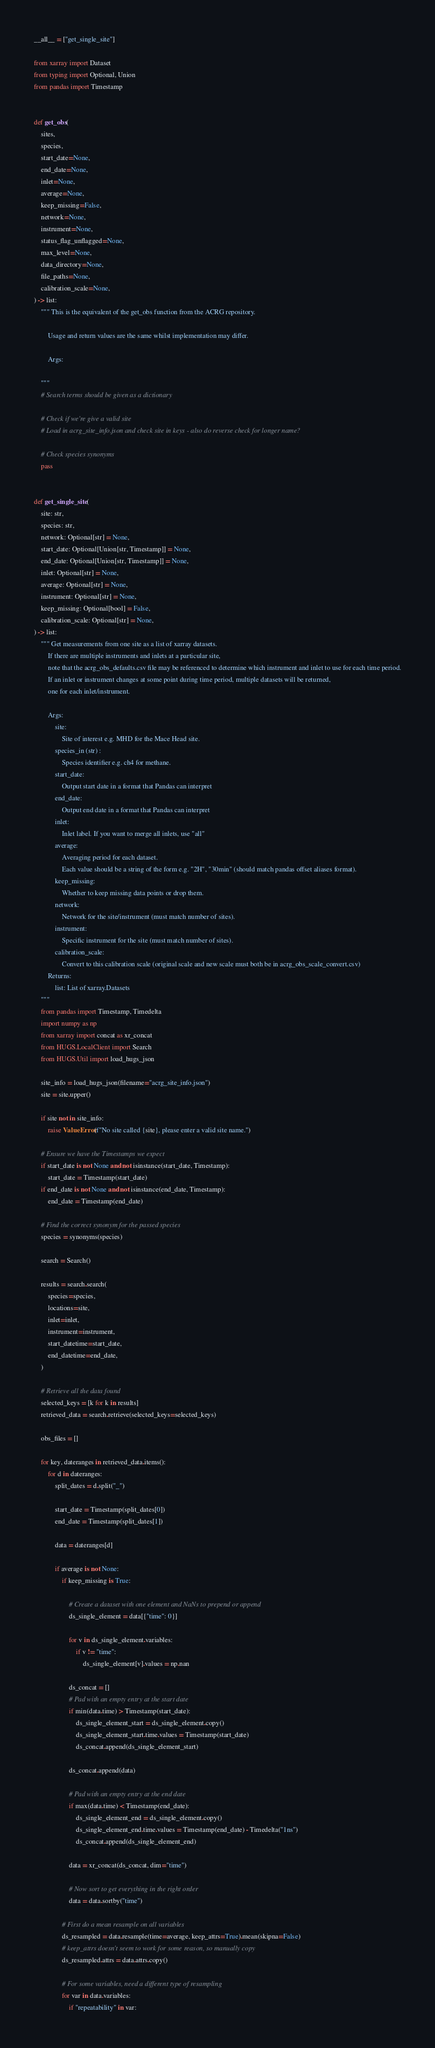<code> <loc_0><loc_0><loc_500><loc_500><_Python_>__all__ = ["get_single_site"]

from xarray import Dataset
from typing import Optional, Union
from pandas import Timestamp


def get_obs(
    sites,
    species,
    start_date=None,
    end_date=None,
    inlet=None,
    average=None,
    keep_missing=False,
    network=None,
    instrument=None,
    status_flag_unflagged=None,
    max_level=None,
    data_directory=None,
    file_paths=None,
    calibration_scale=None,
) -> list:
    """ This is the equivalent of the get_obs function from the ACRG repository.

        Usage and return values are the same whilst implementation may differ.

        Args:

    """
    # Search terms should be given as a dictionary

    # Check if we're give a valid site
    # Load in acrg_site_info.json and check site in keys - also do reverse check for longer name?

    # Check species synonyms
    pass


def get_single_site(
    site: str,
    species: str,
    network: Optional[str] = None,
    start_date: Optional[Union[str, Timestamp]] = None,
    end_date: Optional[Union[str, Timestamp]] = None,
    inlet: Optional[str] = None,
    average: Optional[str] = None,
    instrument: Optional[str] = None,
    keep_missing: Optional[bool] = False,
    calibration_scale: Optional[str] = None,
) -> list:
    """ Get measurements from one site as a list of xarray datasets.
        If there are multiple instruments and inlets at a particular site, 
        note that the acrg_obs_defaults.csv file may be referenced to determine which instrument and inlet to use for each time period.
        If an inlet or instrument changes at some point during time period, multiple datasets will be returned,
        one for each inlet/instrument.

        Args:    
            site:
                Site of interest e.g. MHD for the Mace Head site.
            species_in (str) :
                Species identifier e.g. ch4 for methane.
            start_date: 
                Output start date in a format that Pandas can interpret
            end_date: 
                Output end date in a format that Pandas can interpret
            inlet: 
                Inlet label. If you want to merge all inlets, use "all"
            average:
                Averaging period for each dataset.
                Each value should be a string of the form e.g. "2H", "30min" (should match pandas offset aliases format).
            keep_missing:
                Whether to keep missing data points or drop them.
            network: 
                Network for the site/instrument (must match number of sites).
            instrument:
                Specific instrument for the site (must match number of sites). 
            calibration_scale:
                Convert to this calibration scale (original scale and new scale must both be in acrg_obs_scale_convert.csv)
        Returns:
            list: List of xarray.Datasets
    """
    from pandas import Timestamp, Timedelta
    import numpy as np
    from xarray import concat as xr_concat
    from HUGS.LocalClient import Search
    from HUGS.Util import load_hugs_json

    site_info = load_hugs_json(filename="acrg_site_info.json")
    site = site.upper()

    if site not in site_info:
        raise ValueError(f"No site called {site}, please enter a valid site name.")

    # Ensure we have the Timestamps we expect
    if start_date is not None and not isinstance(start_date, Timestamp):
        start_date = Timestamp(start_date)
    if end_date is not None and not isinstance(end_date, Timestamp):
        end_date = Timestamp(end_date)

    # Find the correct synonym for the passed species
    species = synonyms(species)

    search = Search()

    results = search.search(
        species=species,
        locations=site,
        inlet=inlet,
        instrument=instrument,
        start_datetime=start_date,
        end_datetime=end_date,
    )

    # Retrieve all the data found
    selected_keys = [k for k in results]
    retrieved_data = search.retrieve(selected_keys=selected_keys)

    obs_files = []

    for key, dateranges in retrieved_data.items():
        for d in dateranges:
            split_dates = d.split("_")

            start_date = Timestamp(split_dates[0])
            end_date = Timestamp(split_dates[1])

            data = dateranges[d]

            if average is not None:
                if keep_missing is True:

                    # Create a dataset with one element and NaNs to prepend or append
                    ds_single_element = data[{"time": 0}]

                    for v in ds_single_element.variables:
                        if v != "time":
                            ds_single_element[v].values = np.nan

                    ds_concat = []
                    # Pad with an empty entry at the start date
                    if min(data.time) > Timestamp(start_date):
                        ds_single_element_start = ds_single_element.copy()
                        ds_single_element_start.time.values = Timestamp(start_date)
                        ds_concat.append(ds_single_element_start)

                    ds_concat.append(data)

                    # Pad with an empty entry at the end date
                    if max(data.time) < Timestamp(end_date):
                        ds_single_element_end = ds_single_element.copy()
                        ds_single_element_end.time.values = Timestamp(end_date) - Timedelta("1ns")
                        ds_concat.append(ds_single_element_end)

                    data = xr_concat(ds_concat, dim="time")

                    # Now sort to get everything in the right order
                    data = data.sortby("time")

                # First do a mean resample on all variables
                ds_resampled = data.resample(time=average, keep_attrs=True).mean(skipna=False)
                # keep_attrs doesn't seem to work for some reason, so manually copy
                ds_resampled.attrs = data.attrs.copy()

                # For some variables, need a different type of resampling
                for var in data.variables:
                    if "repeatability" in var:</code> 